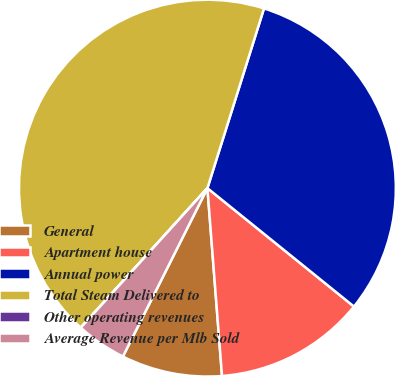<chart> <loc_0><loc_0><loc_500><loc_500><pie_chart><fcel>General<fcel>Apartment house<fcel>Annual power<fcel>Total Steam Delivered to<fcel>Other operating revenues<fcel>Average Revenue per Mlb Sold<nl><fcel>8.64%<fcel>12.95%<fcel>30.96%<fcel>43.12%<fcel>0.01%<fcel>4.32%<nl></chart> 